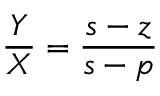Convert formula to latex. <formula><loc_0><loc_0><loc_500><loc_500>{ \frac { Y } { X } } = { \frac { s - z } { s - p } }</formula> 